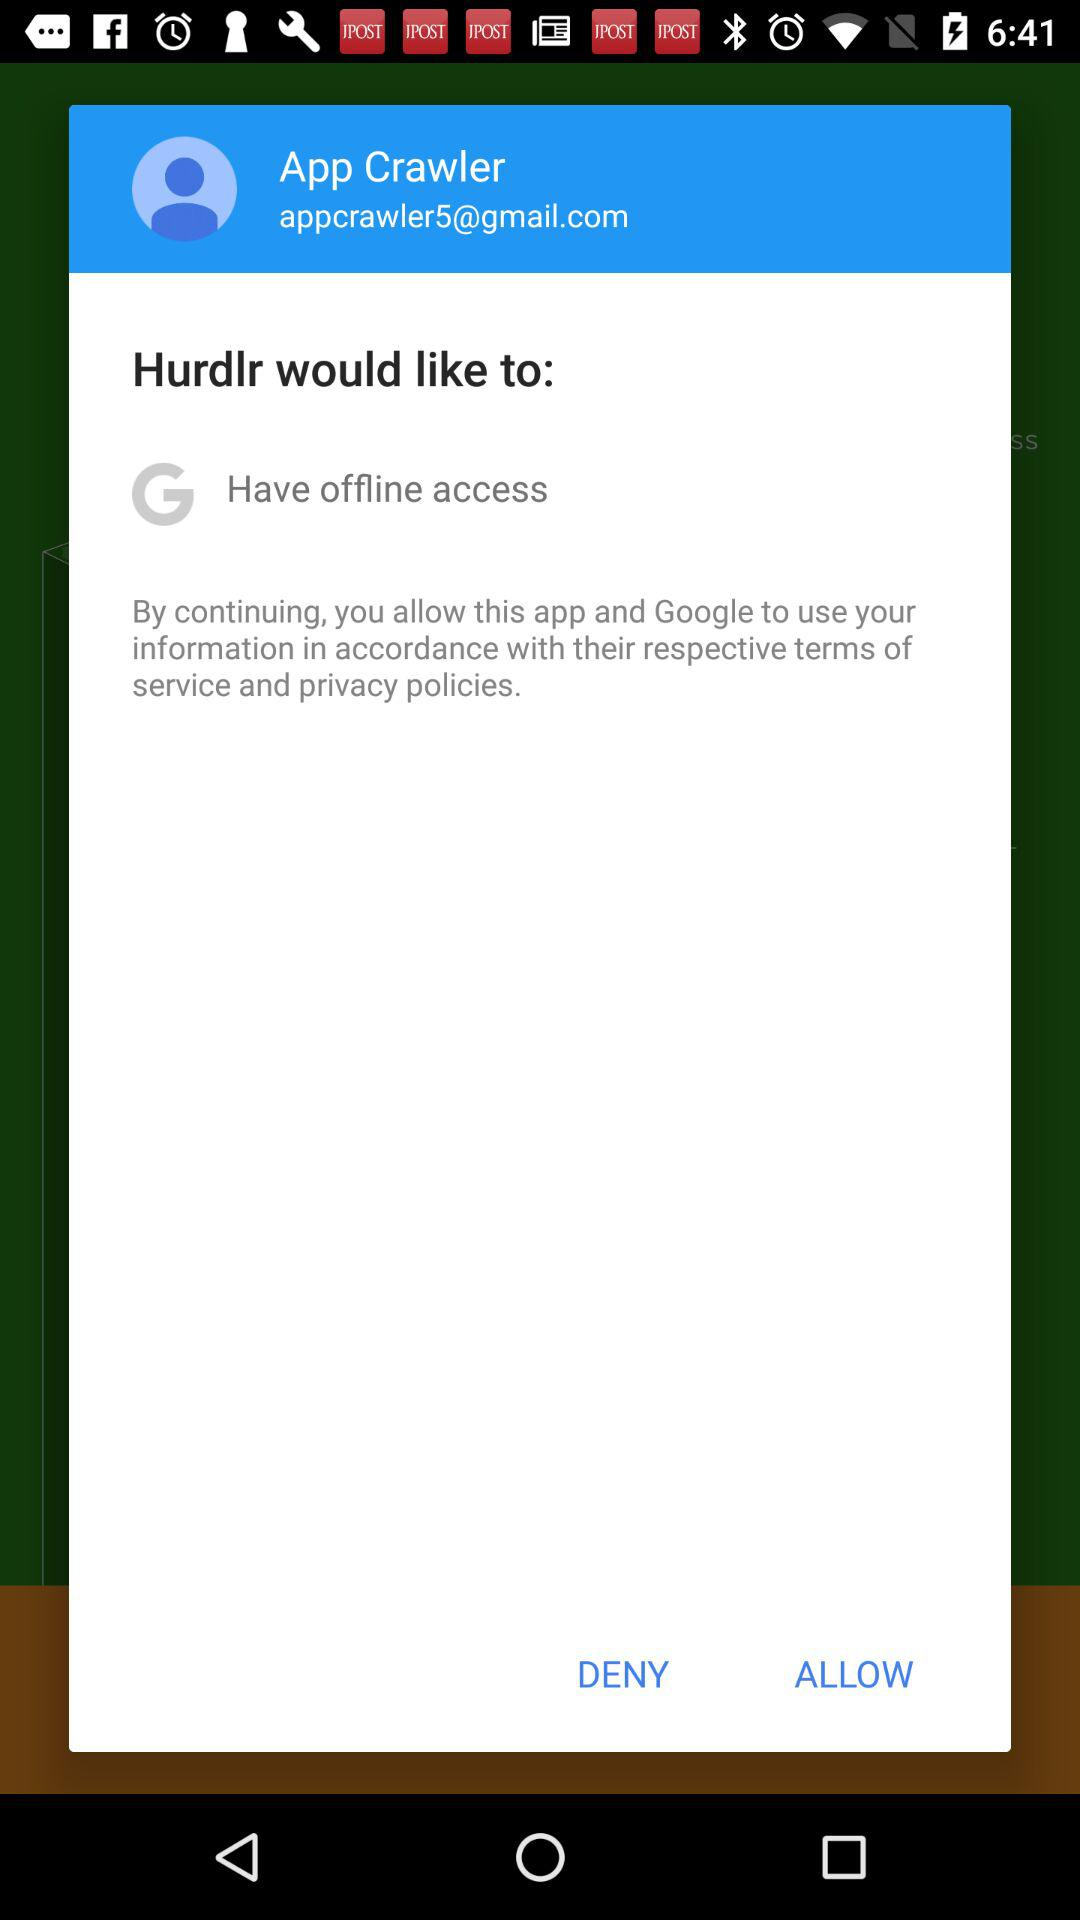What is the email address? The email address is appcrawler5@gmail.com. 